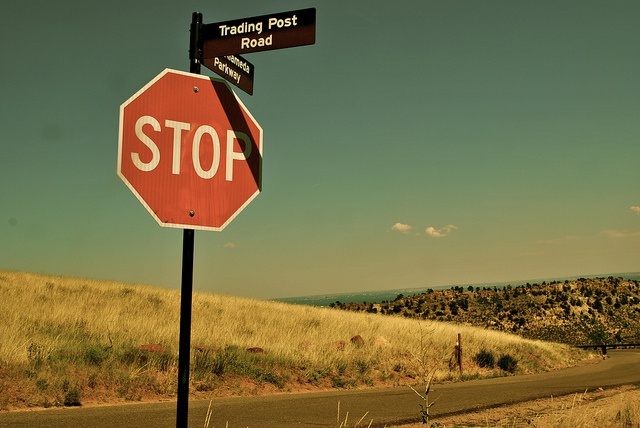Describe the objects in this image and their specific colors. I can see a stop sign in darkgreen, red, brown, tan, and black tones in this image. 